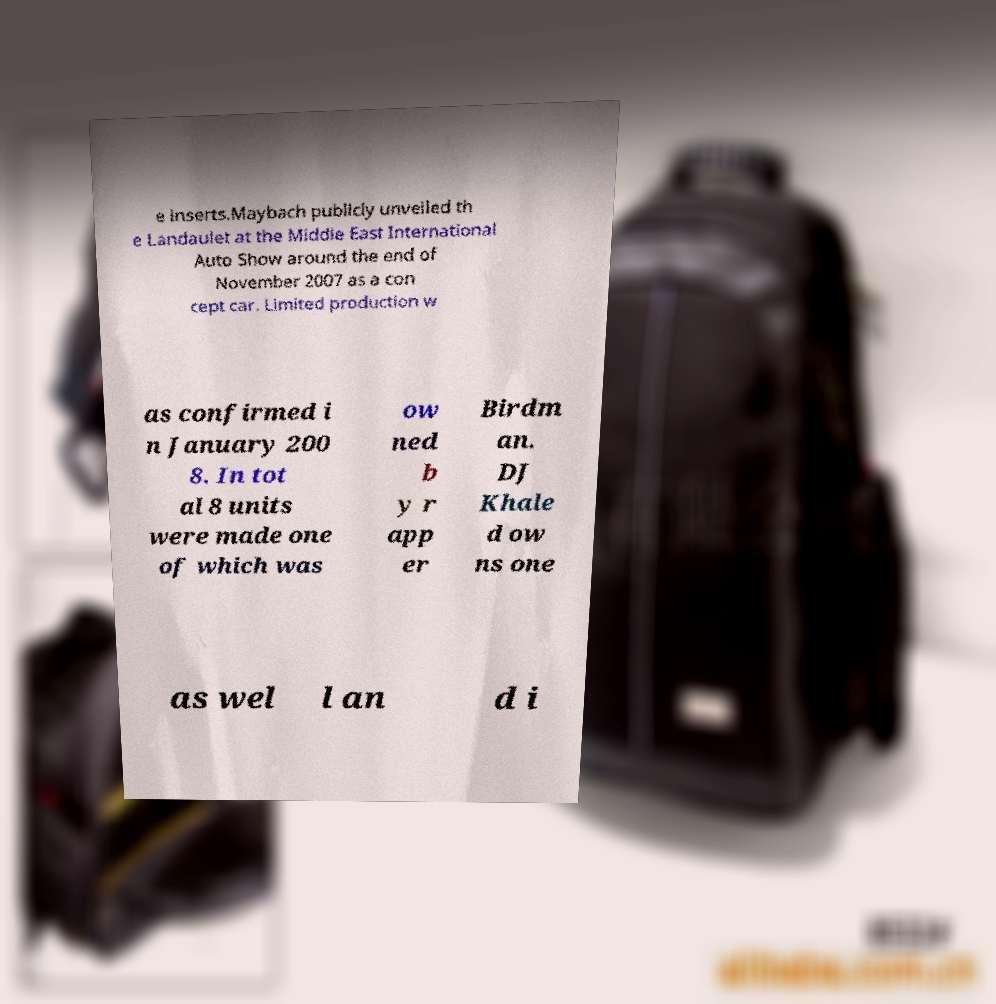Please read and relay the text visible in this image. What does it say? e inserts.Maybach publicly unveiled th e Landaulet at the Middle East International Auto Show around the end of November 2007 as a con cept car. Limited production w as confirmed i n January 200 8. In tot al 8 units were made one of which was ow ned b y r app er Birdm an. DJ Khale d ow ns one as wel l an d i 